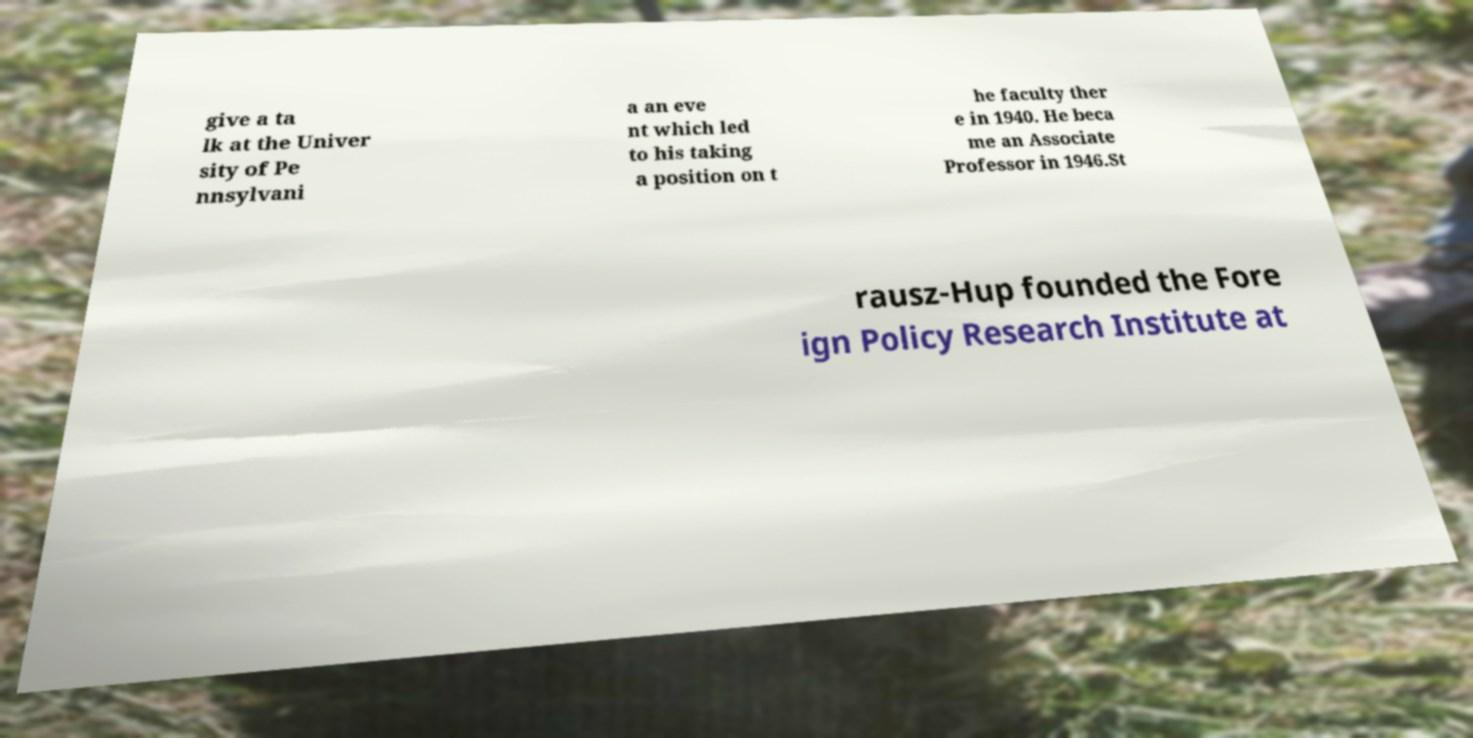Could you extract and type out the text from this image? give a ta lk at the Univer sity of Pe nnsylvani a an eve nt which led to his taking a position on t he faculty ther e in 1940. He beca me an Associate Professor in 1946.St rausz-Hup founded the Fore ign Policy Research Institute at 